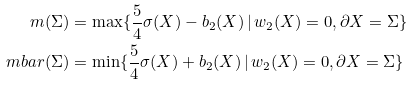<formula> <loc_0><loc_0><loc_500><loc_500>m ( \Sigma ) & = \max \{ \frac { 5 } { 4 } \sigma ( X ) - b _ { 2 } ( X ) \, | \, w _ { 2 } ( X ) = 0 , \partial X = \Sigma \} \\ \ m b a r ( \Sigma ) & = \min \{ \frac { 5 } { 4 } \sigma ( X ) + b _ { 2 } ( X ) \, | \, w _ { 2 } ( X ) = 0 , \partial X = \Sigma \}</formula> 